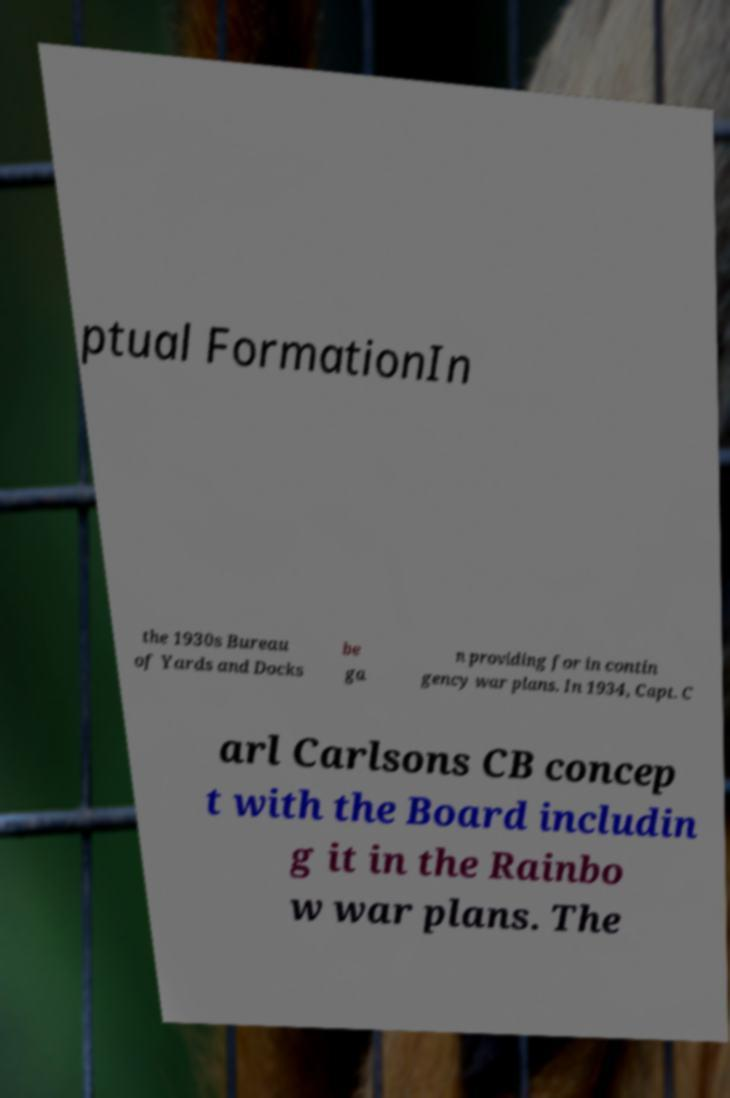Could you assist in decoding the text presented in this image and type it out clearly? ptual FormationIn the 1930s Bureau of Yards and Docks be ga n providing for in contin gency war plans. In 1934, Capt. C arl Carlsons CB concep t with the Board includin g it in the Rainbo w war plans. The 